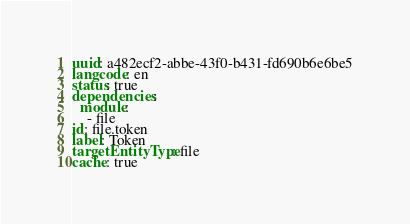<code> <loc_0><loc_0><loc_500><loc_500><_YAML_>uuid: a482ecf2-abbe-43f0-b431-fd690b6e6be5
langcode: en
status: true
dependencies:
  module:
    - file
id: file.token
label: Token
targetEntityType: file
cache: true
</code> 